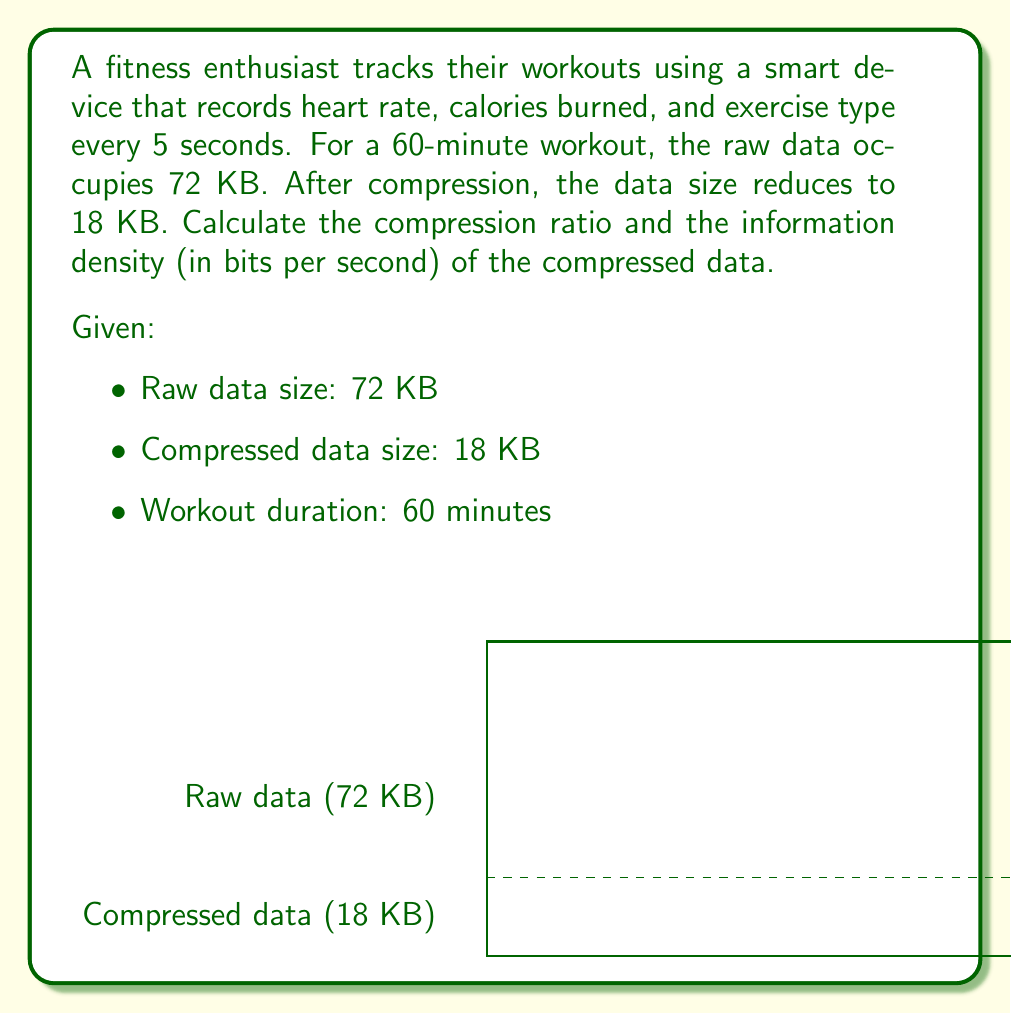Help me with this question. Let's approach this problem step by step:

1. Calculate the compression ratio:
   Compression ratio = (Original size) / (Compressed size)
   $$ \text{Compression ratio} = \frac{72 \text{ KB}}{18 \text{ KB}} = 4 $$

2. Convert the compressed data size from KB to bits:
   $18 \text{ KB} = 18 \times 1024 \times 8 \text{ bits} = 147,456 \text{ bits}$

3. Convert the workout duration from minutes to seconds:
   $60 \text{ minutes} = 60 \times 60 \text{ seconds} = 3600 \text{ seconds}$

4. Calculate the information density in bits per second:
   $$ \text{Information density} = \frac{\text{Compressed data size (bits)}}{\text{Workout duration (seconds)}} $$
   $$ \text{Information density} = \frac{147,456 \text{ bits}}{3600 \text{ seconds}} = 40.96 \text{ bits/second} $$
Answer: Compression ratio: 4, Information density: 40.96 bits/second 